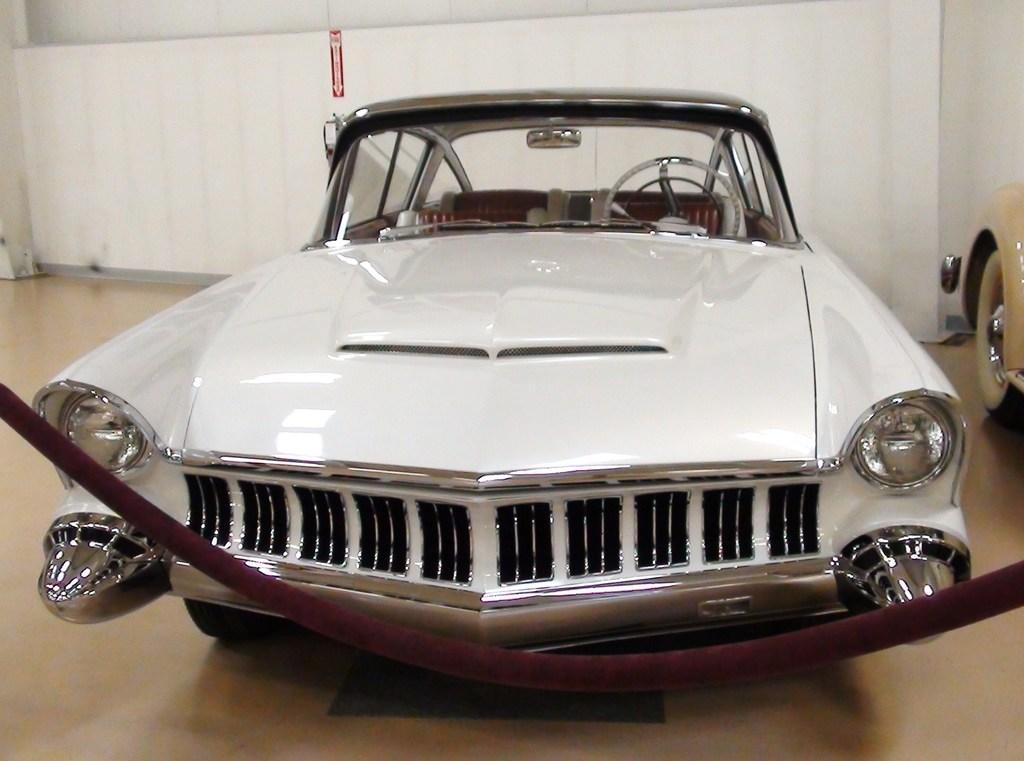Can you describe this image briefly? In this image there are cars, in the background there is a wall. 